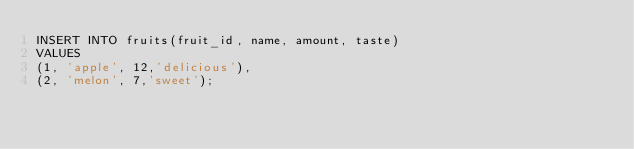Convert code to text. <code><loc_0><loc_0><loc_500><loc_500><_SQL_>INSERT INTO fruits(fruit_id, name, amount, taste)
VALUES 
(1, 'apple', 12,'delicious'),
(2, 'melon', 7,'sweet');</code> 